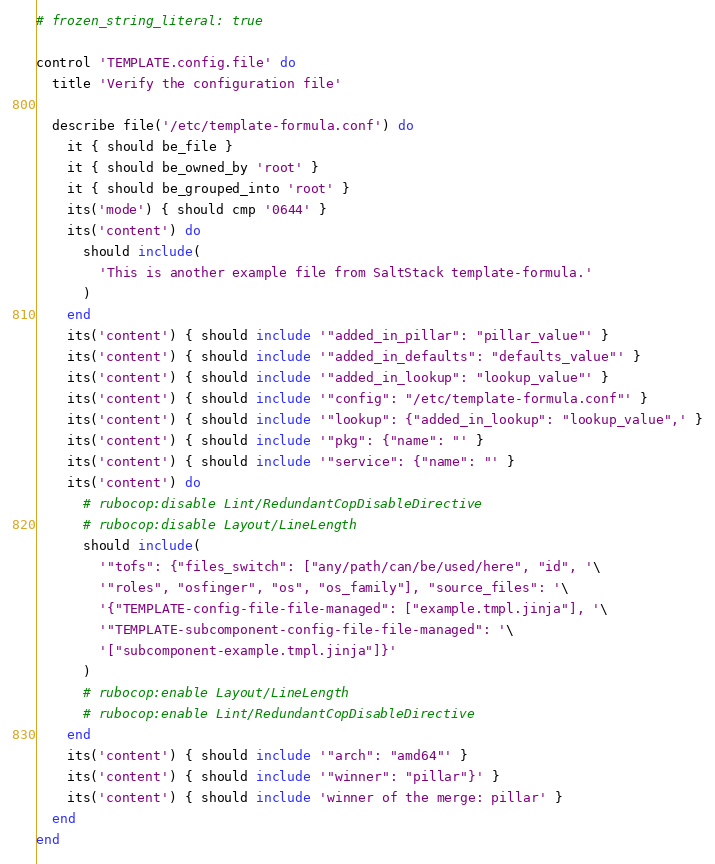Convert code to text. <code><loc_0><loc_0><loc_500><loc_500><_Ruby_># frozen_string_literal: true

control 'TEMPLATE.config.file' do
  title 'Verify the configuration file'

  describe file('/etc/template-formula.conf') do
    it { should be_file }
    it { should be_owned_by 'root' }
    it { should be_grouped_into 'root' }
    its('mode') { should cmp '0644' }
    its('content') do
      should include(
        'This is another example file from SaltStack template-formula.'
      )
    end
    its('content') { should include '"added_in_pillar": "pillar_value"' }
    its('content') { should include '"added_in_defaults": "defaults_value"' }
    its('content') { should include '"added_in_lookup": "lookup_value"' }
    its('content') { should include '"config": "/etc/template-formula.conf"' }
    its('content') { should include '"lookup": {"added_in_lookup": "lookup_value",' }
    its('content') { should include '"pkg": {"name": "' }
    its('content') { should include '"service": {"name": "' }
    its('content') do
      # rubocop:disable Lint/RedundantCopDisableDirective
      # rubocop:disable Layout/LineLength
      should include(
        '"tofs": {"files_switch": ["any/path/can/be/used/here", "id", '\
        '"roles", "osfinger", "os", "os_family"], "source_files": '\
        '{"TEMPLATE-config-file-file-managed": ["example.tmpl.jinja"], '\
        '"TEMPLATE-subcomponent-config-file-file-managed": '\
        '["subcomponent-example.tmpl.jinja"]}'
      )
      # rubocop:enable Layout/LineLength
      # rubocop:enable Lint/RedundantCopDisableDirective
    end
    its('content') { should include '"arch": "amd64"' }
    its('content') { should include '"winner": "pillar"}' }
    its('content') { should include 'winner of the merge: pillar' }
  end
end
</code> 